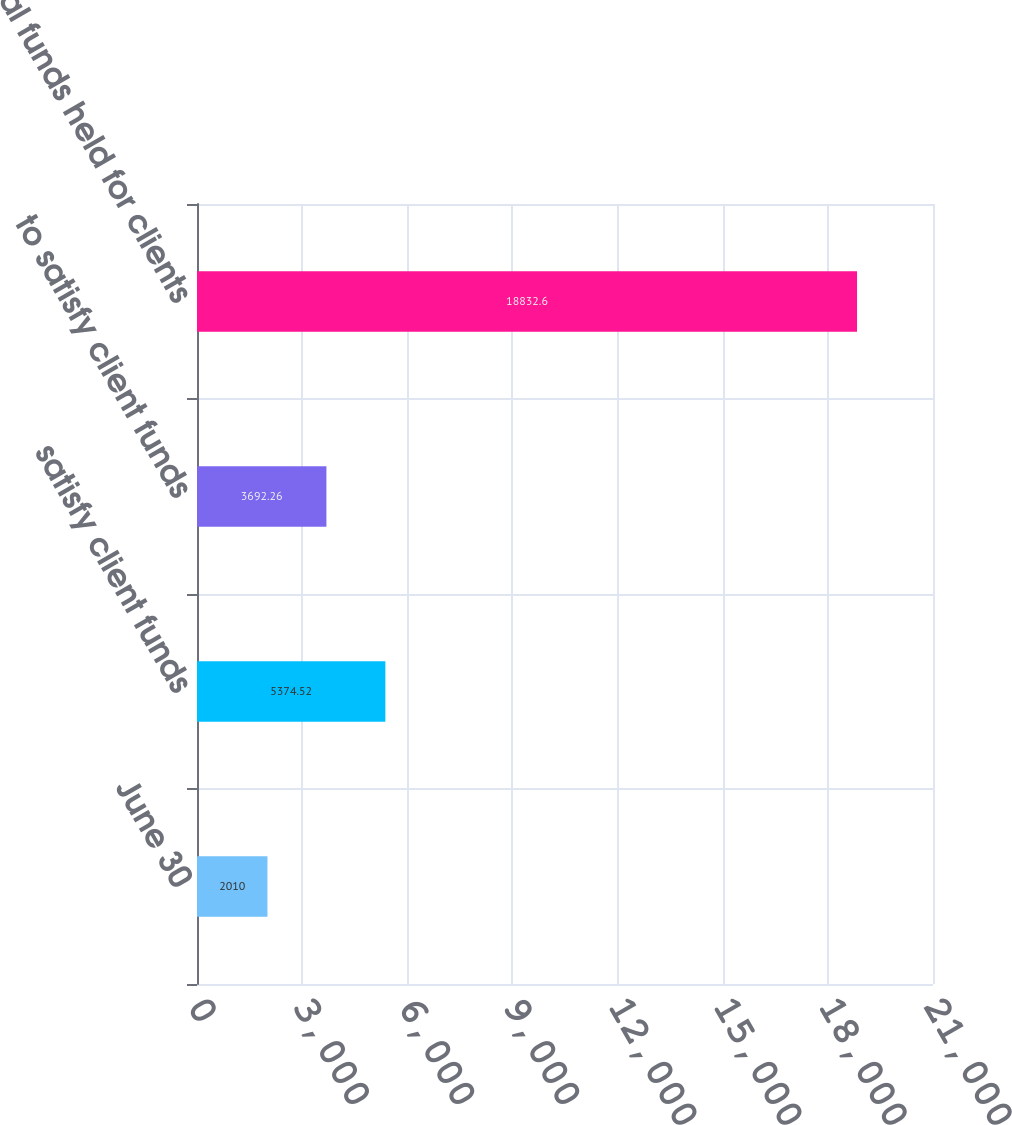Convert chart. <chart><loc_0><loc_0><loc_500><loc_500><bar_chart><fcel>June 30<fcel>satisfy client funds<fcel>to satisfy client funds<fcel>Total funds held for clients<nl><fcel>2010<fcel>5374.52<fcel>3692.26<fcel>18832.6<nl></chart> 